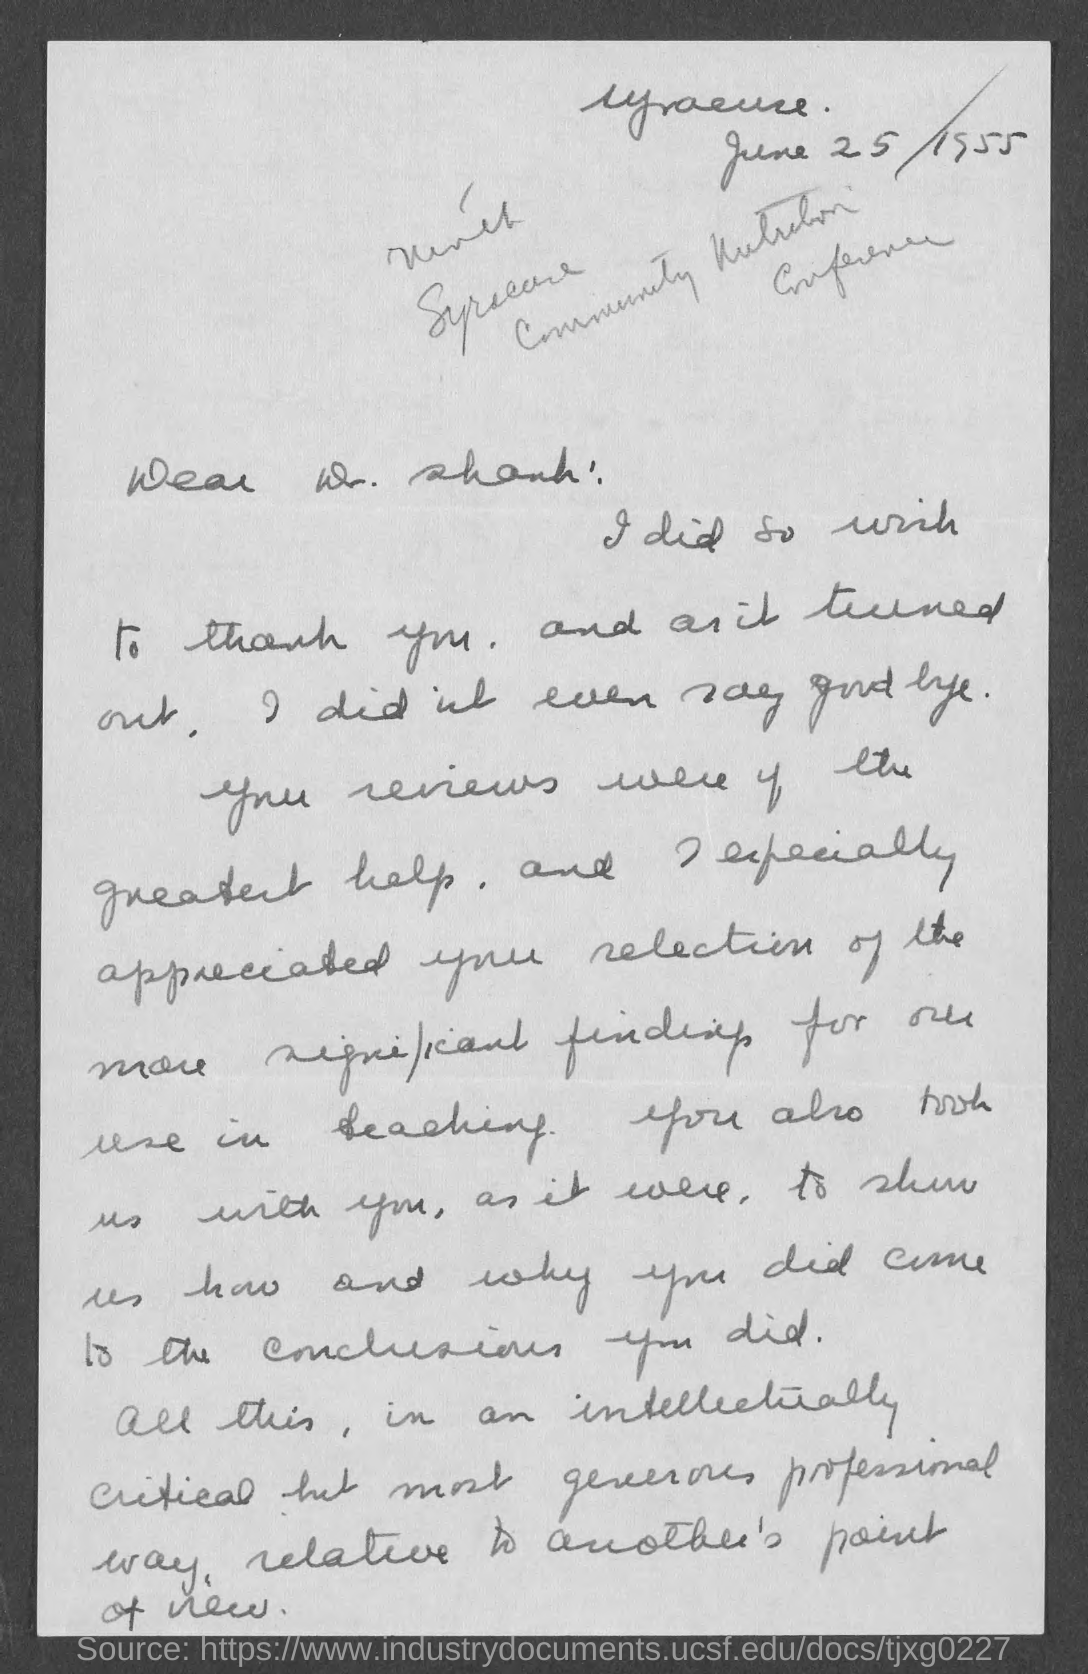To whom is the letter addressed?
Provide a short and direct response. Dr. Shank. 